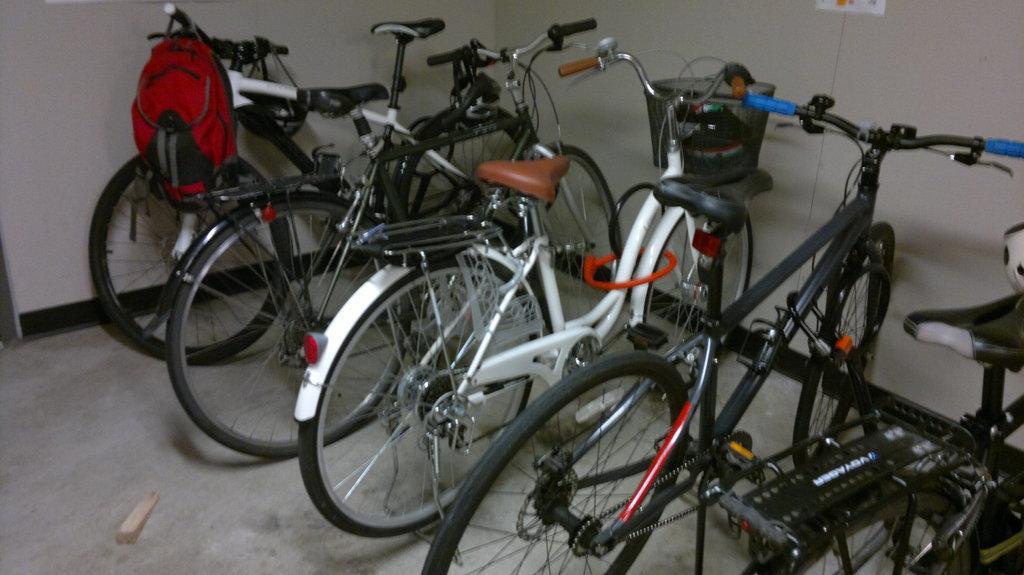How would you summarize this image in a sentence or two? In this picture we can observe some bicycles on the floor. There is a red color bag hanged to the handle of this bicycle. In the background we can observe a white color wall. 